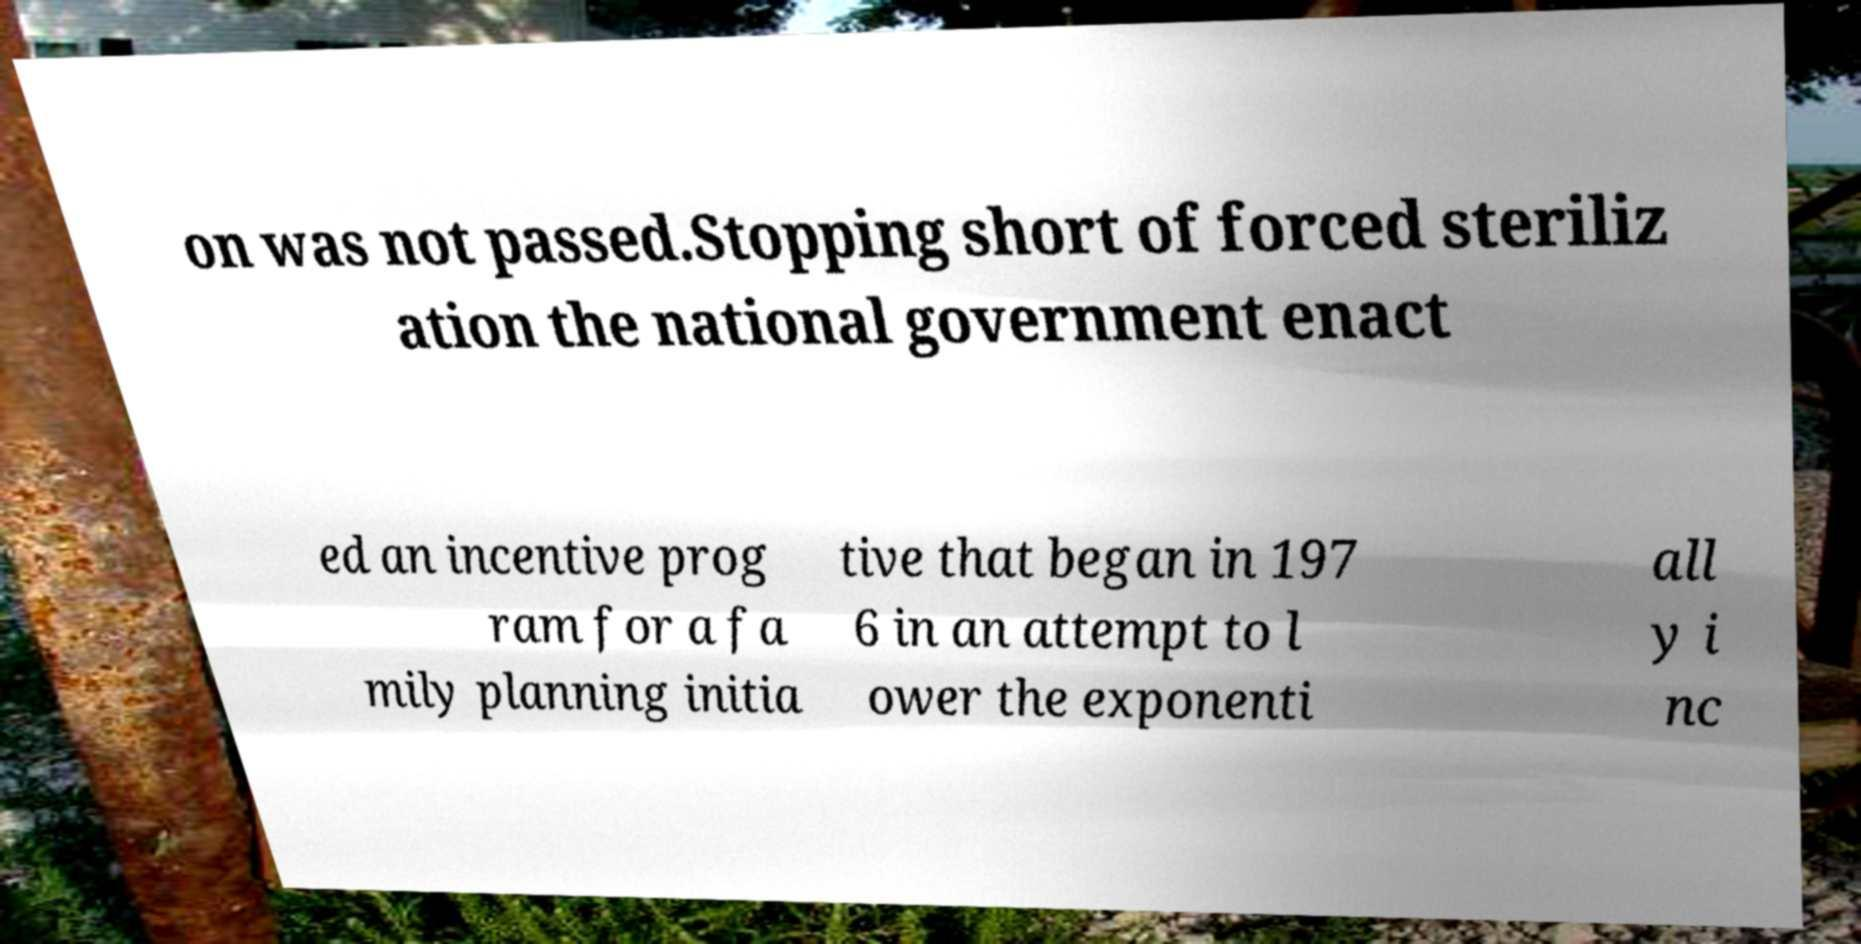Please read and relay the text visible in this image. What does it say? on was not passed.Stopping short of forced steriliz ation the national government enact ed an incentive prog ram for a fa mily planning initia tive that began in 197 6 in an attempt to l ower the exponenti all y i nc 